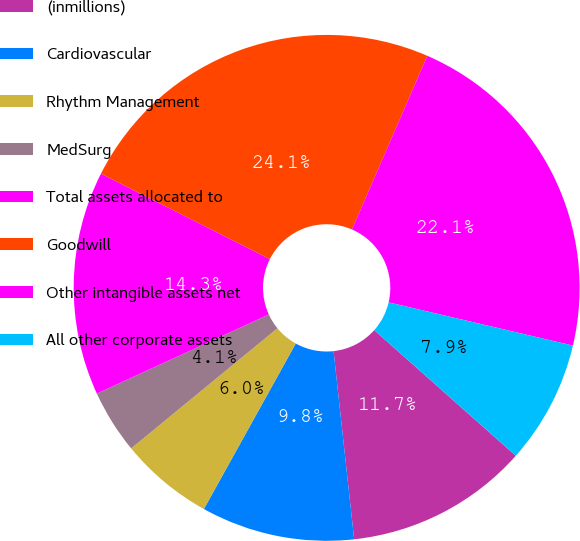Convert chart. <chart><loc_0><loc_0><loc_500><loc_500><pie_chart><fcel>(inmillions)<fcel>Cardiovascular<fcel>Rhythm Management<fcel>MedSurg<fcel>Total assets allocated to<fcel>Goodwill<fcel>Other intangible assets net<fcel>All other corporate assets<nl><fcel>11.71%<fcel>9.8%<fcel>5.99%<fcel>4.08%<fcel>14.32%<fcel>24.06%<fcel>22.15%<fcel>7.89%<nl></chart> 